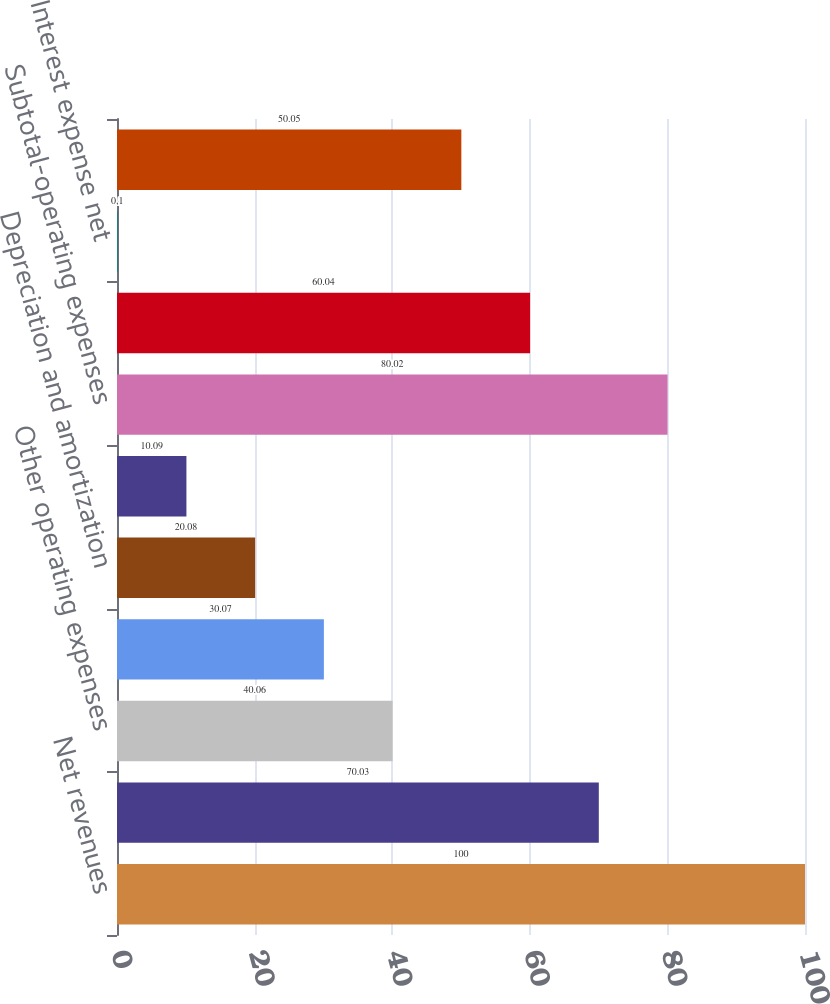Convert chart to OTSL. <chart><loc_0><loc_0><loc_500><loc_500><bar_chart><fcel>Net revenues<fcel>Salaries wages and benefits<fcel>Other operating expenses<fcel>Supplies expense<fcel>Depreciation and amortization<fcel>Lease and rental expense<fcel>Subtotal-operating expenses<fcel>Income from operations<fcel>Interest expense net<fcel>Income before income taxes<nl><fcel>100<fcel>70.03<fcel>40.06<fcel>30.07<fcel>20.08<fcel>10.09<fcel>80.02<fcel>60.04<fcel>0.1<fcel>50.05<nl></chart> 